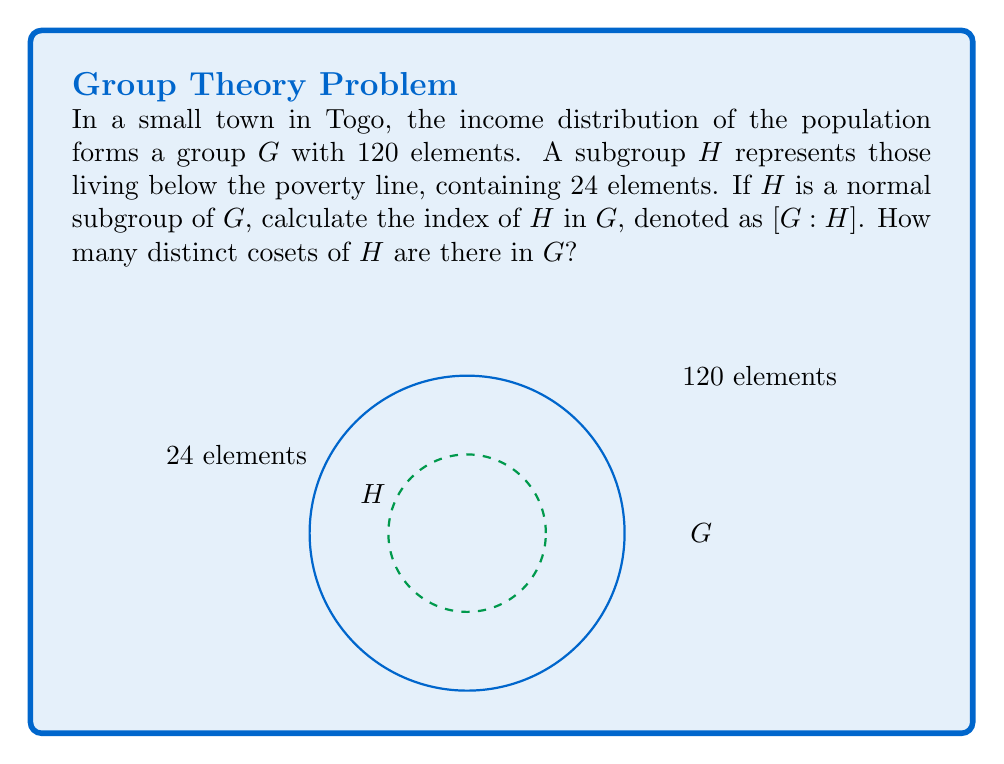Solve this math problem. To solve this problem, we'll follow these steps:

1) Recall that for a subgroup $H$ of a group $G$, the index $[G:H]$ is defined as the number of distinct left (or right) cosets of $H$ in $G$.

2) For finite groups, the index is equal to the quotient of the orders of the groups:

   $$[G:H] = \frac{|G|}{|H|}$$

   where $|G|$ and $|H|$ represent the number of elements in $G$ and $H$ respectively.

3) In this case:
   $|G| = 120$ (total population)
   $|H| = 24$ (population below poverty line)

4) Substituting these values:

   $$[G:H] = \frac{120}{24}$$

5) Simplify:
   $$[G:H] = 5$$

6) The index $[G:H] = 5$ means there are 5 distinct cosets of $H$ in $G$.

This result indicates that the population can be divided into 5 distinct income brackets based on multiples of the poverty line income.
Answer: $[G:H] = 5$ 